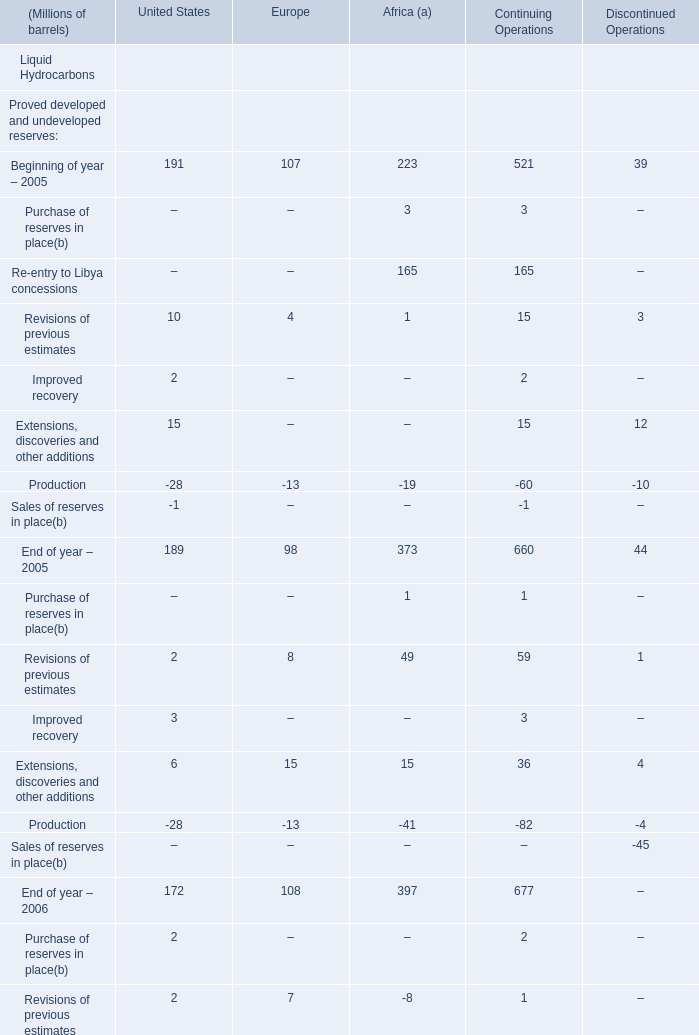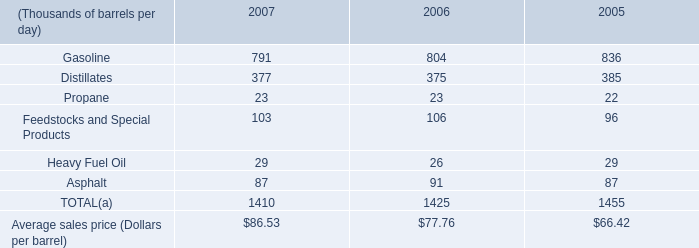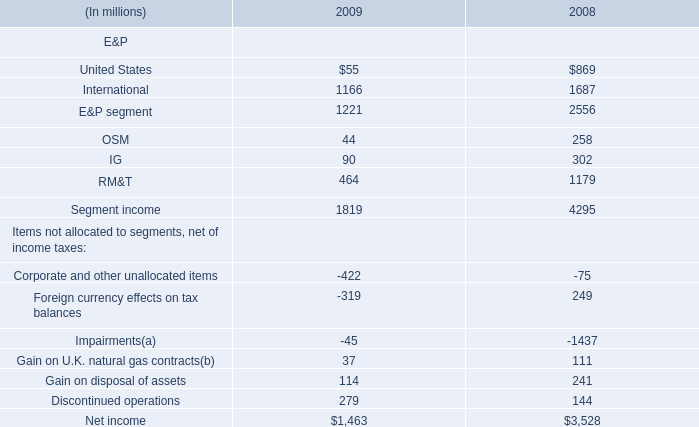what was the decline in matching buy/sell volumes in mbpd between 2006 and 2005? 
Computations: (24 - 77)
Answer: -53.0. 